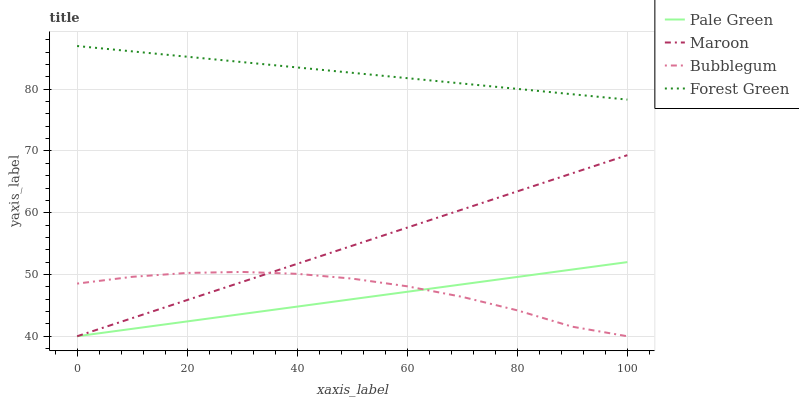Does Pale Green have the minimum area under the curve?
Answer yes or no. Yes. Does Forest Green have the maximum area under the curve?
Answer yes or no. Yes. Does Bubblegum have the minimum area under the curve?
Answer yes or no. No. Does Bubblegum have the maximum area under the curve?
Answer yes or no. No. Is Maroon the smoothest?
Answer yes or no. Yes. Is Bubblegum the roughest?
Answer yes or no. Yes. Is Pale Green the smoothest?
Answer yes or no. No. Is Pale Green the roughest?
Answer yes or no. No. Does Pale Green have the lowest value?
Answer yes or no. Yes. Does Forest Green have the highest value?
Answer yes or no. Yes. Does Pale Green have the highest value?
Answer yes or no. No. Is Bubblegum less than Forest Green?
Answer yes or no. Yes. Is Forest Green greater than Maroon?
Answer yes or no. Yes. Does Pale Green intersect Bubblegum?
Answer yes or no. Yes. Is Pale Green less than Bubblegum?
Answer yes or no. No. Is Pale Green greater than Bubblegum?
Answer yes or no. No. Does Bubblegum intersect Forest Green?
Answer yes or no. No. 